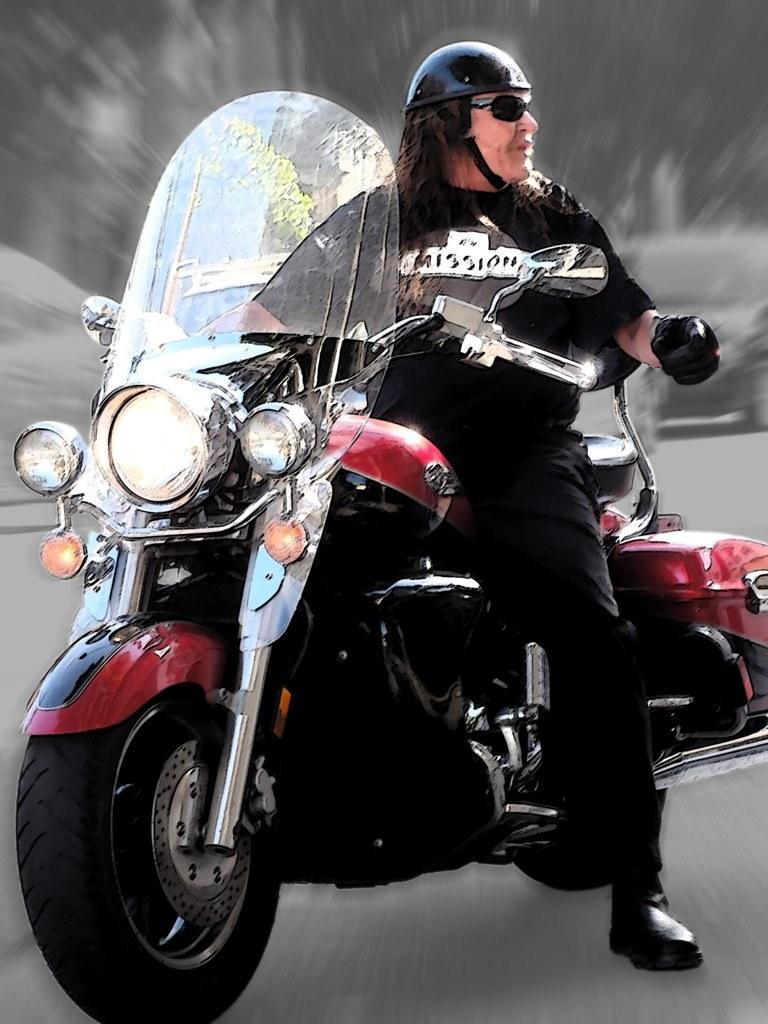Who is present in the image? There is a man in the image. What protective gear is the man wearing? The man is wearing a helmet and goggles. What is the man doing in the image? The man is sitting on a bike. Can you describe the background of the image? The background of the image is blurry. What type of record is the scarecrow holding in the image? There is no scarecrow or record present in the image. 